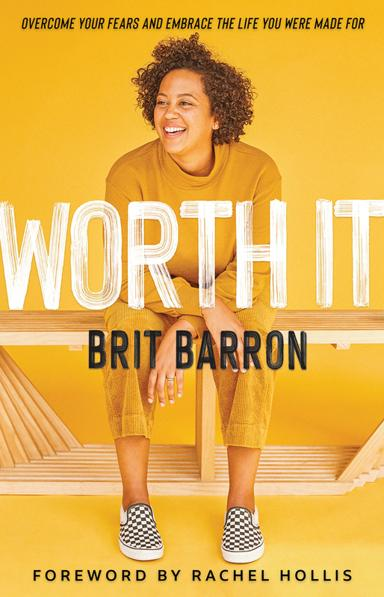What are some key themes discussed in this book? This book primarily focuses on themes such as personal growth, overcoming fears, and self-empowerment. Brit Barron shares her insights on how individuals can push past their perceived limits and fully embrace the lives they are meant to live. 